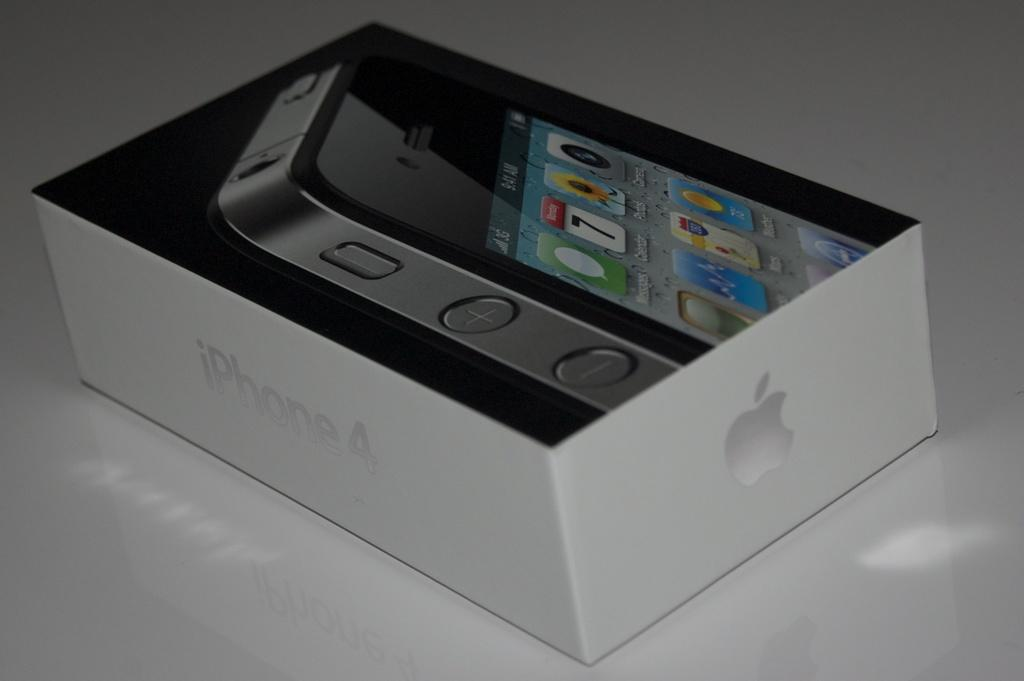<image>
Offer a succinct explanation of the picture presented. An iphone box that says iphone 4 on the side of it. 